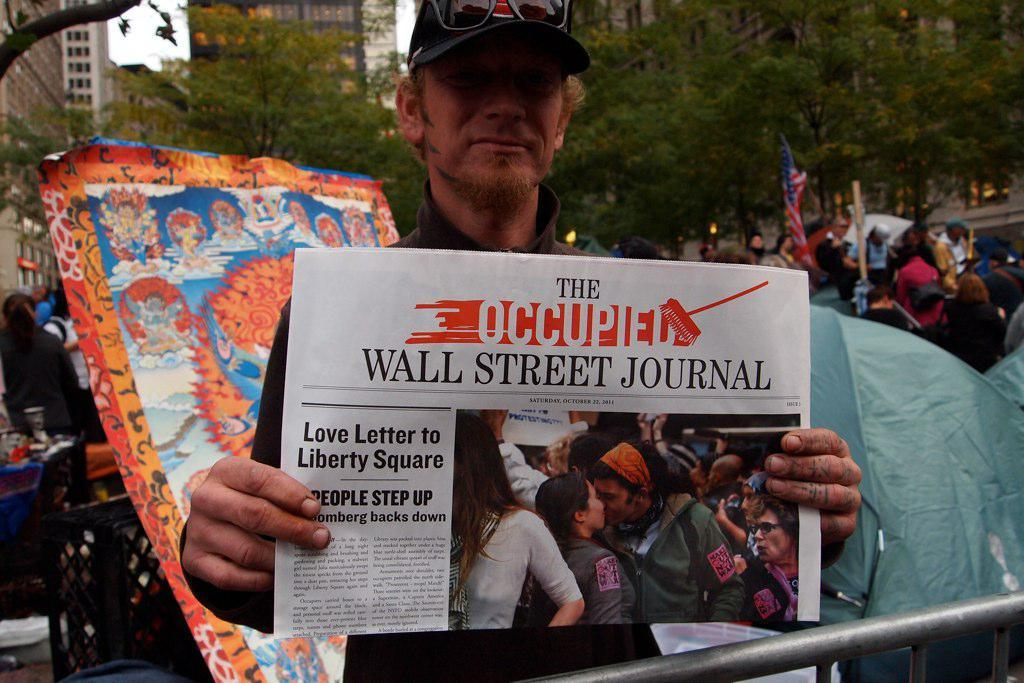<image>
Write a terse but informative summary of the picture. A man holding a newspaper which headlines The Occupied by the Wall Street Journal. 